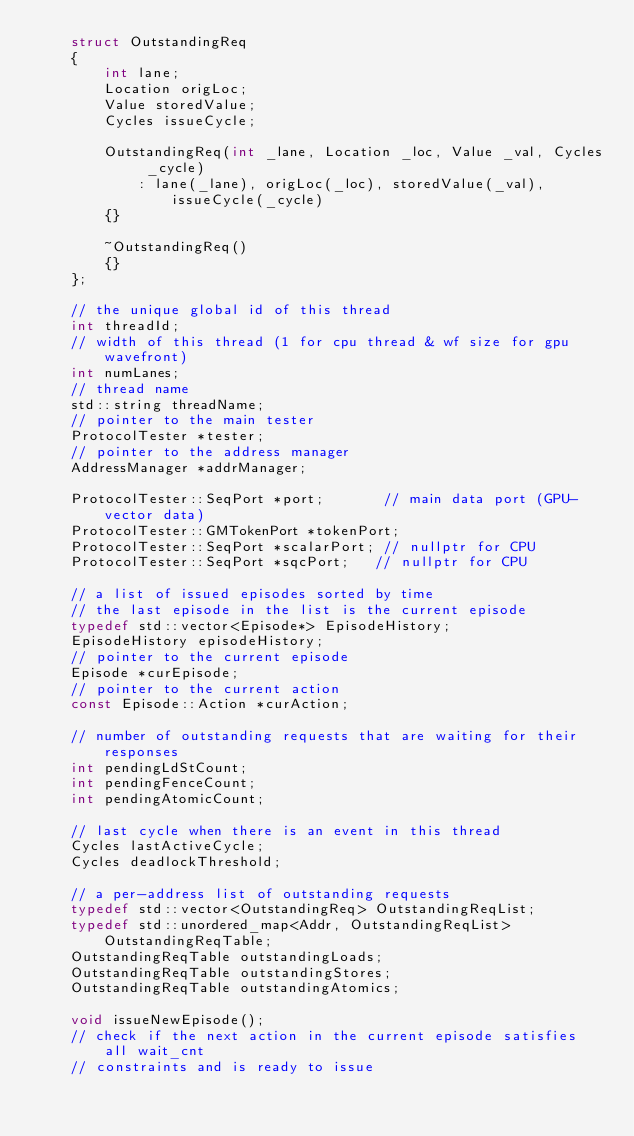<code> <loc_0><loc_0><loc_500><loc_500><_C++_>    struct OutstandingReq
    {
        int lane;
        Location origLoc;
        Value storedValue;
        Cycles issueCycle;

        OutstandingReq(int _lane, Location _loc, Value _val, Cycles _cycle)
            : lane(_lane), origLoc(_loc), storedValue(_val), issueCycle(_cycle)
        {}

        ~OutstandingReq()
        {}
    };

    // the unique global id of this thread
    int threadId;
    // width of this thread (1 for cpu thread & wf size for gpu wavefront)
    int numLanes;
    // thread name
    std::string threadName;
    // pointer to the main tester
    ProtocolTester *tester;
    // pointer to the address manager
    AddressManager *addrManager;

    ProtocolTester::SeqPort *port;       // main data port (GPU-vector data)
    ProtocolTester::GMTokenPort *tokenPort;
    ProtocolTester::SeqPort *scalarPort; // nullptr for CPU
    ProtocolTester::SeqPort *sqcPort;   // nullptr for CPU

    // a list of issued episodes sorted by time
    // the last episode in the list is the current episode
    typedef std::vector<Episode*> EpisodeHistory;
    EpisodeHistory episodeHistory;
    // pointer to the current episode
    Episode *curEpisode;
    // pointer to the current action
    const Episode::Action *curAction;

    // number of outstanding requests that are waiting for their responses
    int pendingLdStCount;
    int pendingFenceCount;
    int pendingAtomicCount;

    // last cycle when there is an event in this thread
    Cycles lastActiveCycle;
    Cycles deadlockThreshold;

    // a per-address list of outstanding requests
    typedef std::vector<OutstandingReq> OutstandingReqList;
    typedef std::unordered_map<Addr, OutstandingReqList> OutstandingReqTable;
    OutstandingReqTable outstandingLoads;
    OutstandingReqTable outstandingStores;
    OutstandingReqTable outstandingAtomics;

    void issueNewEpisode();
    // check if the next action in the current episode satisfies all wait_cnt
    // constraints and is ready to issue</code> 